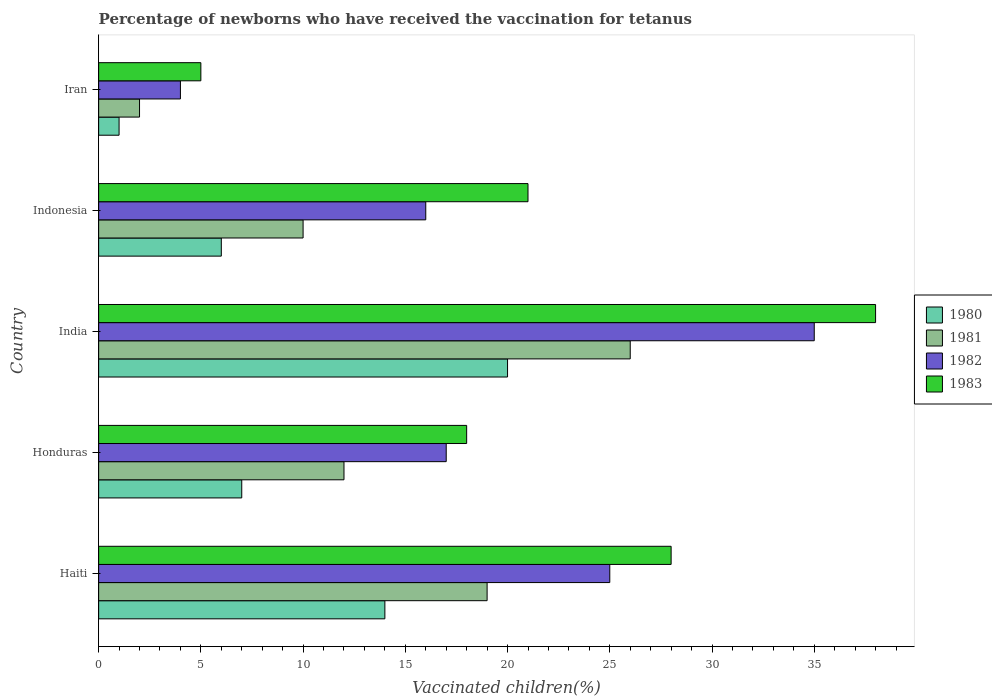Are the number of bars per tick equal to the number of legend labels?
Provide a short and direct response. Yes. How many bars are there on the 3rd tick from the top?
Offer a very short reply. 4. How many bars are there on the 5th tick from the bottom?
Offer a terse response. 4. What is the label of the 5th group of bars from the top?
Keep it short and to the point. Haiti. In how many cases, is the number of bars for a given country not equal to the number of legend labels?
Provide a short and direct response. 0. Across all countries, what is the minimum percentage of vaccinated children in 1980?
Offer a terse response. 1. In which country was the percentage of vaccinated children in 1983 minimum?
Offer a terse response. Iran. What is the total percentage of vaccinated children in 1982 in the graph?
Your answer should be compact. 97. What is the difference between the percentage of vaccinated children in 1983 in Honduras and the percentage of vaccinated children in 1982 in Indonesia?
Provide a short and direct response. 2. What is the ratio of the percentage of vaccinated children in 1980 in Honduras to that in Indonesia?
Give a very brief answer. 1.17. What is the difference between the highest and the second highest percentage of vaccinated children in 1982?
Make the answer very short. 10. In how many countries, is the percentage of vaccinated children in 1981 greater than the average percentage of vaccinated children in 1981 taken over all countries?
Give a very brief answer. 2. Is the sum of the percentage of vaccinated children in 1981 in Honduras and Iran greater than the maximum percentage of vaccinated children in 1980 across all countries?
Keep it short and to the point. No. Is it the case that in every country, the sum of the percentage of vaccinated children in 1981 and percentage of vaccinated children in 1982 is greater than the sum of percentage of vaccinated children in 1980 and percentage of vaccinated children in 1983?
Give a very brief answer. No. What does the 1st bar from the top in Haiti represents?
Ensure brevity in your answer.  1983. Is it the case that in every country, the sum of the percentage of vaccinated children in 1981 and percentage of vaccinated children in 1983 is greater than the percentage of vaccinated children in 1982?
Keep it short and to the point. Yes. How many countries are there in the graph?
Give a very brief answer. 5. Does the graph contain any zero values?
Offer a terse response. No. Where does the legend appear in the graph?
Your answer should be compact. Center right. How many legend labels are there?
Ensure brevity in your answer.  4. What is the title of the graph?
Ensure brevity in your answer.  Percentage of newborns who have received the vaccination for tetanus. Does "1971" appear as one of the legend labels in the graph?
Your response must be concise. No. What is the label or title of the X-axis?
Your answer should be very brief. Vaccinated children(%). What is the label or title of the Y-axis?
Keep it short and to the point. Country. What is the Vaccinated children(%) of 1982 in Haiti?
Your answer should be compact. 25. What is the Vaccinated children(%) in 1983 in Haiti?
Your answer should be compact. 28. What is the Vaccinated children(%) of 1982 in Honduras?
Ensure brevity in your answer.  17. What is the Vaccinated children(%) in 1981 in India?
Provide a succinct answer. 26. What is the Vaccinated children(%) of 1982 in India?
Provide a short and direct response. 35. What is the Vaccinated children(%) in 1983 in India?
Keep it short and to the point. 38. What is the Vaccinated children(%) in 1980 in Indonesia?
Keep it short and to the point. 6. What is the Vaccinated children(%) in 1982 in Indonesia?
Keep it short and to the point. 16. What is the Vaccinated children(%) of 1980 in Iran?
Provide a short and direct response. 1. What is the Vaccinated children(%) in 1981 in Iran?
Provide a succinct answer. 2. What is the Vaccinated children(%) of 1982 in Iran?
Your answer should be compact. 4. Across all countries, what is the minimum Vaccinated children(%) of 1980?
Offer a terse response. 1. What is the total Vaccinated children(%) in 1980 in the graph?
Offer a very short reply. 48. What is the total Vaccinated children(%) of 1982 in the graph?
Provide a succinct answer. 97. What is the total Vaccinated children(%) in 1983 in the graph?
Make the answer very short. 110. What is the difference between the Vaccinated children(%) of 1982 in Haiti and that in Honduras?
Provide a succinct answer. 8. What is the difference between the Vaccinated children(%) of 1982 in Haiti and that in India?
Give a very brief answer. -10. What is the difference between the Vaccinated children(%) of 1982 in Haiti and that in Indonesia?
Your answer should be very brief. 9. What is the difference between the Vaccinated children(%) of 1983 in Haiti and that in Indonesia?
Provide a succinct answer. 7. What is the difference between the Vaccinated children(%) of 1981 in Haiti and that in Iran?
Make the answer very short. 17. What is the difference between the Vaccinated children(%) of 1983 in Haiti and that in Iran?
Your answer should be compact. 23. What is the difference between the Vaccinated children(%) of 1982 in Honduras and that in India?
Offer a terse response. -18. What is the difference between the Vaccinated children(%) of 1983 in Honduras and that in India?
Offer a very short reply. -20. What is the difference between the Vaccinated children(%) of 1980 in Honduras and that in Indonesia?
Offer a very short reply. 1. What is the difference between the Vaccinated children(%) of 1981 in Honduras and that in Indonesia?
Your response must be concise. 2. What is the difference between the Vaccinated children(%) in 1983 in Honduras and that in Indonesia?
Provide a succinct answer. -3. What is the difference between the Vaccinated children(%) in 1980 in Honduras and that in Iran?
Your response must be concise. 6. What is the difference between the Vaccinated children(%) of 1982 in Honduras and that in Iran?
Offer a very short reply. 13. What is the difference between the Vaccinated children(%) of 1983 in Honduras and that in Iran?
Ensure brevity in your answer.  13. What is the difference between the Vaccinated children(%) of 1980 in India and that in Indonesia?
Offer a terse response. 14. What is the difference between the Vaccinated children(%) of 1981 in India and that in Indonesia?
Make the answer very short. 16. What is the difference between the Vaccinated children(%) of 1982 in India and that in Indonesia?
Give a very brief answer. 19. What is the difference between the Vaccinated children(%) in 1981 in India and that in Iran?
Your response must be concise. 24. What is the difference between the Vaccinated children(%) in 1982 in India and that in Iran?
Your response must be concise. 31. What is the difference between the Vaccinated children(%) in 1980 in Indonesia and that in Iran?
Ensure brevity in your answer.  5. What is the difference between the Vaccinated children(%) in 1983 in Indonesia and that in Iran?
Make the answer very short. 16. What is the difference between the Vaccinated children(%) of 1980 in Haiti and the Vaccinated children(%) of 1981 in Honduras?
Ensure brevity in your answer.  2. What is the difference between the Vaccinated children(%) in 1981 in Haiti and the Vaccinated children(%) in 1982 in Honduras?
Offer a very short reply. 2. What is the difference between the Vaccinated children(%) in 1981 in Haiti and the Vaccinated children(%) in 1983 in Honduras?
Your response must be concise. 1. What is the difference between the Vaccinated children(%) of 1982 in Haiti and the Vaccinated children(%) of 1983 in Honduras?
Your response must be concise. 7. What is the difference between the Vaccinated children(%) of 1981 in Haiti and the Vaccinated children(%) of 1982 in India?
Offer a terse response. -16. What is the difference between the Vaccinated children(%) in 1982 in Haiti and the Vaccinated children(%) in 1983 in India?
Make the answer very short. -13. What is the difference between the Vaccinated children(%) in 1980 in Haiti and the Vaccinated children(%) in 1981 in Indonesia?
Make the answer very short. 4. What is the difference between the Vaccinated children(%) in 1980 in Haiti and the Vaccinated children(%) in 1982 in Indonesia?
Your response must be concise. -2. What is the difference between the Vaccinated children(%) in 1981 in Haiti and the Vaccinated children(%) in 1982 in Indonesia?
Provide a succinct answer. 3. What is the difference between the Vaccinated children(%) of 1981 in Haiti and the Vaccinated children(%) of 1983 in Indonesia?
Your response must be concise. -2. What is the difference between the Vaccinated children(%) in 1980 in Haiti and the Vaccinated children(%) in 1982 in Iran?
Offer a very short reply. 10. What is the difference between the Vaccinated children(%) of 1981 in Haiti and the Vaccinated children(%) of 1982 in Iran?
Give a very brief answer. 15. What is the difference between the Vaccinated children(%) of 1981 in Haiti and the Vaccinated children(%) of 1983 in Iran?
Your answer should be very brief. 14. What is the difference between the Vaccinated children(%) in 1980 in Honduras and the Vaccinated children(%) in 1983 in India?
Offer a very short reply. -31. What is the difference between the Vaccinated children(%) of 1981 in Honduras and the Vaccinated children(%) of 1982 in India?
Make the answer very short. -23. What is the difference between the Vaccinated children(%) of 1981 in Honduras and the Vaccinated children(%) of 1983 in India?
Your response must be concise. -26. What is the difference between the Vaccinated children(%) in 1982 in Honduras and the Vaccinated children(%) in 1983 in India?
Provide a succinct answer. -21. What is the difference between the Vaccinated children(%) of 1980 in Honduras and the Vaccinated children(%) of 1981 in Indonesia?
Provide a short and direct response. -3. What is the difference between the Vaccinated children(%) of 1980 in Honduras and the Vaccinated children(%) of 1982 in Indonesia?
Give a very brief answer. -9. What is the difference between the Vaccinated children(%) in 1980 in Honduras and the Vaccinated children(%) in 1983 in Indonesia?
Your answer should be very brief. -14. What is the difference between the Vaccinated children(%) of 1981 in Honduras and the Vaccinated children(%) of 1982 in Indonesia?
Offer a very short reply. -4. What is the difference between the Vaccinated children(%) of 1981 in Honduras and the Vaccinated children(%) of 1983 in Indonesia?
Ensure brevity in your answer.  -9. What is the difference between the Vaccinated children(%) of 1982 in Honduras and the Vaccinated children(%) of 1983 in Iran?
Make the answer very short. 12. What is the difference between the Vaccinated children(%) of 1981 in India and the Vaccinated children(%) of 1983 in Indonesia?
Your answer should be very brief. 5. What is the difference between the Vaccinated children(%) of 1981 in India and the Vaccinated children(%) of 1982 in Iran?
Your answer should be compact. 22. What is the difference between the Vaccinated children(%) of 1982 in India and the Vaccinated children(%) of 1983 in Iran?
Ensure brevity in your answer.  30. What is the difference between the Vaccinated children(%) in 1980 in Indonesia and the Vaccinated children(%) in 1981 in Iran?
Keep it short and to the point. 4. What is the difference between the Vaccinated children(%) of 1980 in Indonesia and the Vaccinated children(%) of 1982 in Iran?
Offer a terse response. 2. What is the difference between the Vaccinated children(%) in 1980 in Indonesia and the Vaccinated children(%) in 1983 in Iran?
Your answer should be very brief. 1. What is the difference between the Vaccinated children(%) of 1981 in Indonesia and the Vaccinated children(%) of 1983 in Iran?
Your response must be concise. 5. What is the average Vaccinated children(%) of 1981 per country?
Keep it short and to the point. 13.8. What is the average Vaccinated children(%) in 1983 per country?
Your response must be concise. 22. What is the difference between the Vaccinated children(%) in 1980 and Vaccinated children(%) in 1982 in Haiti?
Offer a very short reply. -11. What is the difference between the Vaccinated children(%) in 1981 and Vaccinated children(%) in 1983 in Haiti?
Offer a very short reply. -9. What is the difference between the Vaccinated children(%) in 1982 and Vaccinated children(%) in 1983 in Haiti?
Provide a succinct answer. -3. What is the difference between the Vaccinated children(%) of 1980 and Vaccinated children(%) of 1983 in Honduras?
Provide a short and direct response. -11. What is the difference between the Vaccinated children(%) in 1981 and Vaccinated children(%) in 1982 in Honduras?
Provide a succinct answer. -5. What is the difference between the Vaccinated children(%) in 1980 and Vaccinated children(%) in 1981 in India?
Your response must be concise. -6. What is the difference between the Vaccinated children(%) of 1980 and Vaccinated children(%) of 1982 in India?
Your answer should be very brief. -15. What is the difference between the Vaccinated children(%) in 1981 and Vaccinated children(%) in 1982 in India?
Make the answer very short. -9. What is the difference between the Vaccinated children(%) of 1980 and Vaccinated children(%) of 1981 in Indonesia?
Keep it short and to the point. -4. What is the difference between the Vaccinated children(%) in 1980 and Vaccinated children(%) in 1982 in Indonesia?
Offer a very short reply. -10. What is the difference between the Vaccinated children(%) of 1980 and Vaccinated children(%) of 1983 in Indonesia?
Your answer should be very brief. -15. What is the difference between the Vaccinated children(%) in 1981 and Vaccinated children(%) in 1982 in Indonesia?
Offer a very short reply. -6. What is the difference between the Vaccinated children(%) in 1981 and Vaccinated children(%) in 1983 in Indonesia?
Your response must be concise. -11. What is the difference between the Vaccinated children(%) in 1982 and Vaccinated children(%) in 1983 in Indonesia?
Your answer should be compact. -5. What is the difference between the Vaccinated children(%) in 1980 and Vaccinated children(%) in 1982 in Iran?
Provide a succinct answer. -3. What is the difference between the Vaccinated children(%) of 1981 and Vaccinated children(%) of 1983 in Iran?
Offer a very short reply. -3. What is the ratio of the Vaccinated children(%) in 1981 in Haiti to that in Honduras?
Your answer should be compact. 1.58. What is the ratio of the Vaccinated children(%) of 1982 in Haiti to that in Honduras?
Your answer should be very brief. 1.47. What is the ratio of the Vaccinated children(%) in 1983 in Haiti to that in Honduras?
Ensure brevity in your answer.  1.56. What is the ratio of the Vaccinated children(%) of 1981 in Haiti to that in India?
Make the answer very short. 0.73. What is the ratio of the Vaccinated children(%) in 1983 in Haiti to that in India?
Your answer should be compact. 0.74. What is the ratio of the Vaccinated children(%) of 1980 in Haiti to that in Indonesia?
Your answer should be very brief. 2.33. What is the ratio of the Vaccinated children(%) of 1981 in Haiti to that in Indonesia?
Provide a short and direct response. 1.9. What is the ratio of the Vaccinated children(%) of 1982 in Haiti to that in Indonesia?
Your response must be concise. 1.56. What is the ratio of the Vaccinated children(%) in 1981 in Haiti to that in Iran?
Provide a succinct answer. 9.5. What is the ratio of the Vaccinated children(%) in 1982 in Haiti to that in Iran?
Your answer should be compact. 6.25. What is the ratio of the Vaccinated children(%) of 1981 in Honduras to that in India?
Your response must be concise. 0.46. What is the ratio of the Vaccinated children(%) in 1982 in Honduras to that in India?
Make the answer very short. 0.49. What is the ratio of the Vaccinated children(%) of 1983 in Honduras to that in India?
Your response must be concise. 0.47. What is the ratio of the Vaccinated children(%) of 1981 in Honduras to that in Indonesia?
Ensure brevity in your answer.  1.2. What is the ratio of the Vaccinated children(%) of 1983 in Honduras to that in Indonesia?
Give a very brief answer. 0.86. What is the ratio of the Vaccinated children(%) in 1980 in Honduras to that in Iran?
Ensure brevity in your answer.  7. What is the ratio of the Vaccinated children(%) of 1981 in Honduras to that in Iran?
Your response must be concise. 6. What is the ratio of the Vaccinated children(%) of 1982 in Honduras to that in Iran?
Your answer should be compact. 4.25. What is the ratio of the Vaccinated children(%) in 1983 in Honduras to that in Iran?
Give a very brief answer. 3.6. What is the ratio of the Vaccinated children(%) of 1980 in India to that in Indonesia?
Offer a terse response. 3.33. What is the ratio of the Vaccinated children(%) in 1981 in India to that in Indonesia?
Provide a succinct answer. 2.6. What is the ratio of the Vaccinated children(%) in 1982 in India to that in Indonesia?
Make the answer very short. 2.19. What is the ratio of the Vaccinated children(%) in 1983 in India to that in Indonesia?
Offer a very short reply. 1.81. What is the ratio of the Vaccinated children(%) in 1981 in India to that in Iran?
Keep it short and to the point. 13. What is the ratio of the Vaccinated children(%) of 1982 in India to that in Iran?
Your answer should be very brief. 8.75. What is the ratio of the Vaccinated children(%) of 1983 in India to that in Iran?
Offer a terse response. 7.6. What is the ratio of the Vaccinated children(%) in 1983 in Indonesia to that in Iran?
Ensure brevity in your answer.  4.2. What is the difference between the highest and the second highest Vaccinated children(%) of 1983?
Your response must be concise. 10. What is the difference between the highest and the lowest Vaccinated children(%) in 1981?
Your answer should be very brief. 24. What is the difference between the highest and the lowest Vaccinated children(%) in 1982?
Ensure brevity in your answer.  31. What is the difference between the highest and the lowest Vaccinated children(%) in 1983?
Ensure brevity in your answer.  33. 